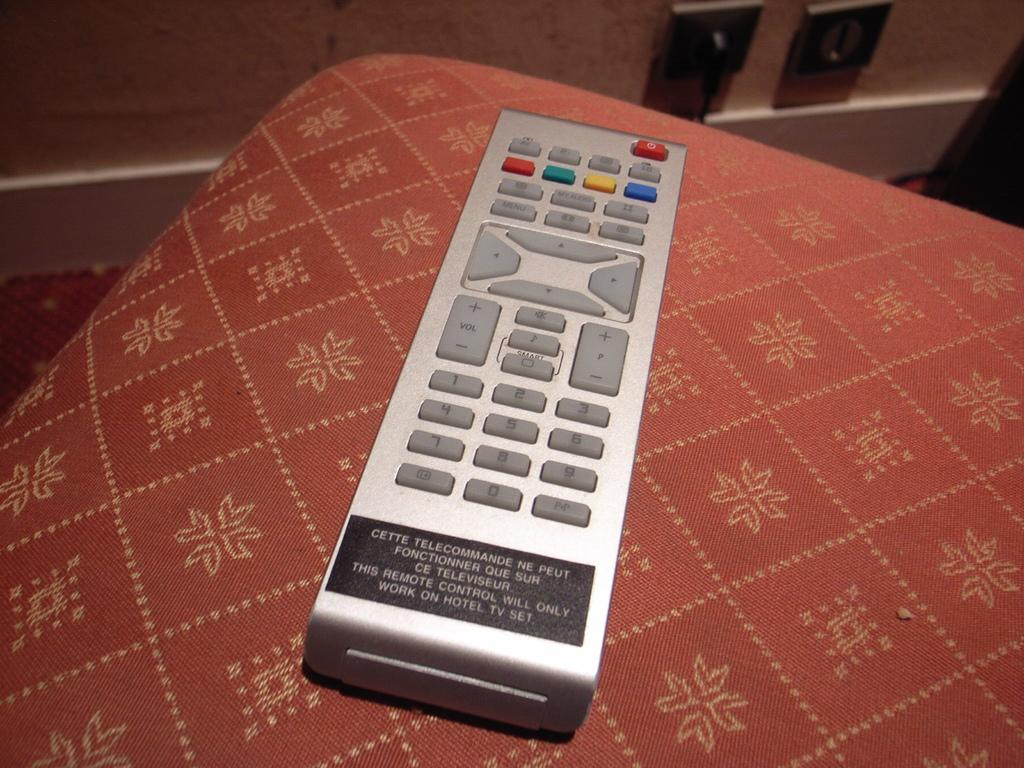<image>
Provide a brief description of the given image. A label on a remote indicates it will only work in the hotel. 